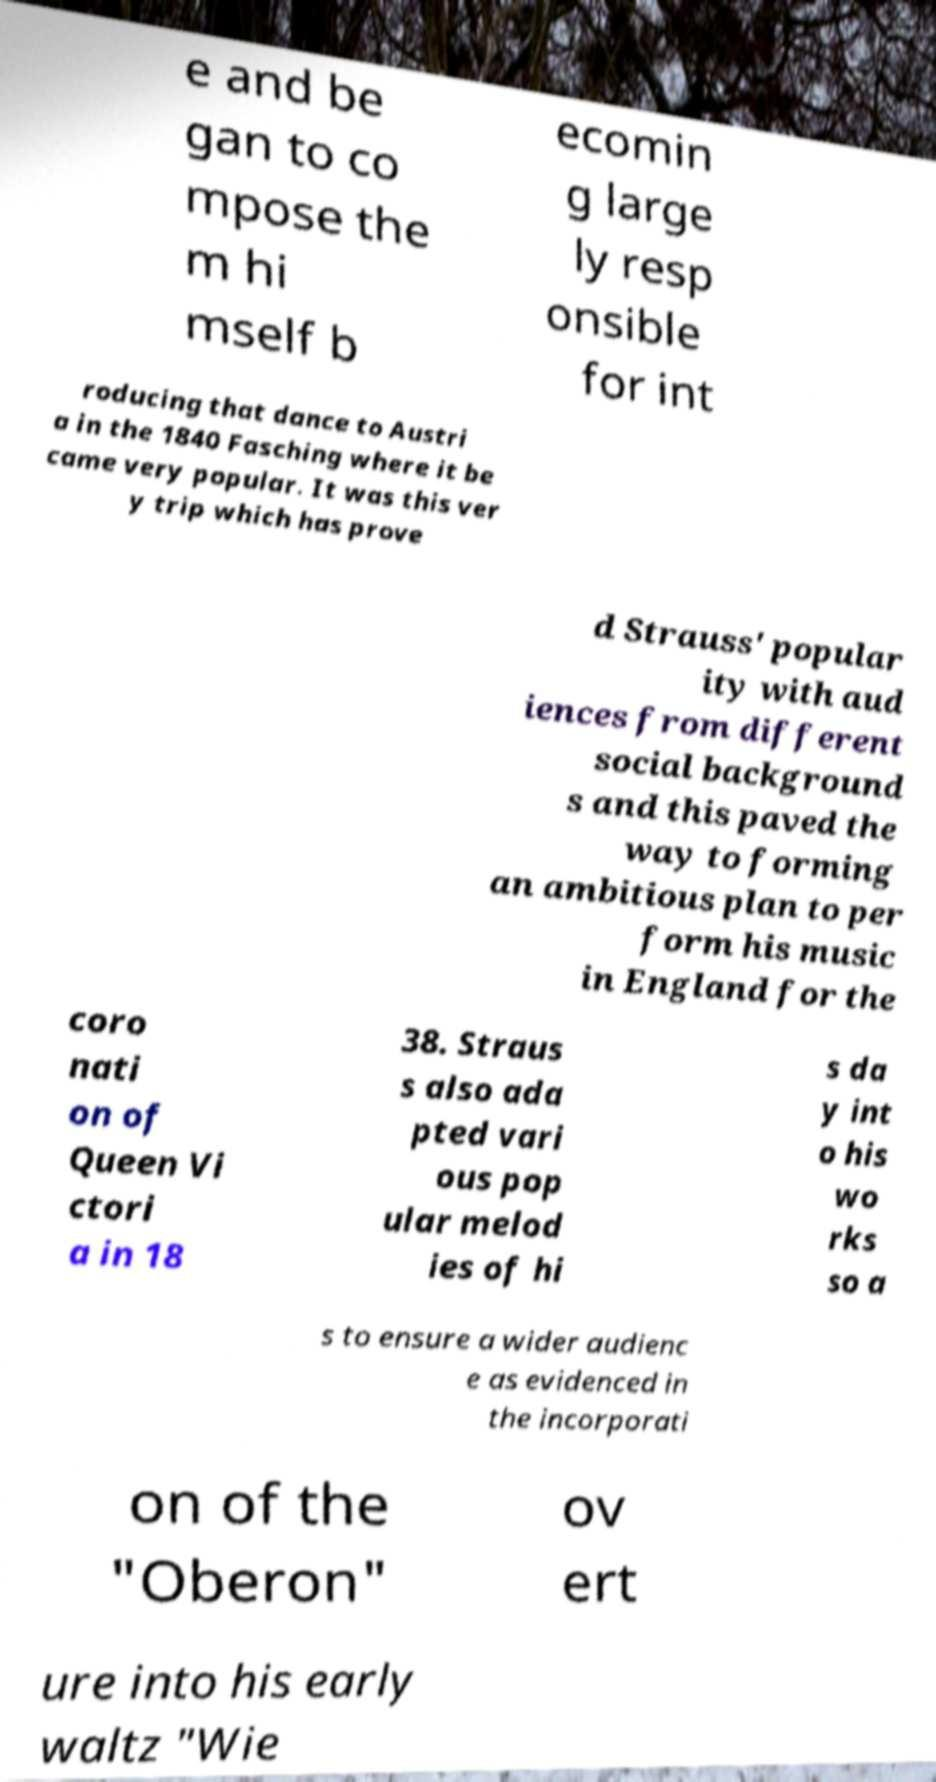Please read and relay the text visible in this image. What does it say? e and be gan to co mpose the m hi mself b ecomin g large ly resp onsible for int roducing that dance to Austri a in the 1840 Fasching where it be came very popular. It was this ver y trip which has prove d Strauss' popular ity with aud iences from different social background s and this paved the way to forming an ambitious plan to per form his music in England for the coro nati on of Queen Vi ctori a in 18 38. Straus s also ada pted vari ous pop ular melod ies of hi s da y int o his wo rks so a s to ensure a wider audienc e as evidenced in the incorporati on of the "Oberon" ov ert ure into his early waltz "Wie 